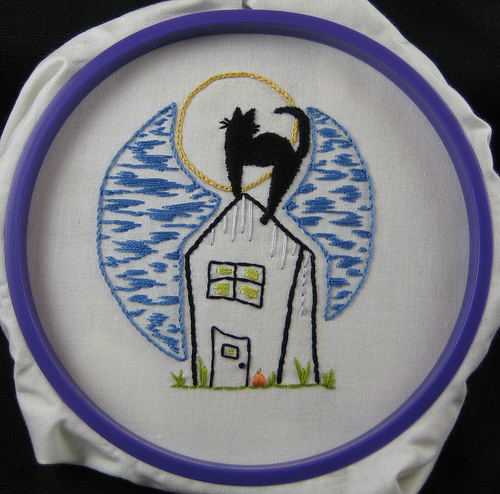<image>
Is the wolf on the bowl? No. The wolf is not positioned on the bowl. They may be near each other, but the wolf is not supported by or resting on top of the bowl. Where is the cat in relation to the moon? Is it on the moon? No. The cat is not positioned on the moon. They may be near each other, but the cat is not supported by or resting on top of the moon. 